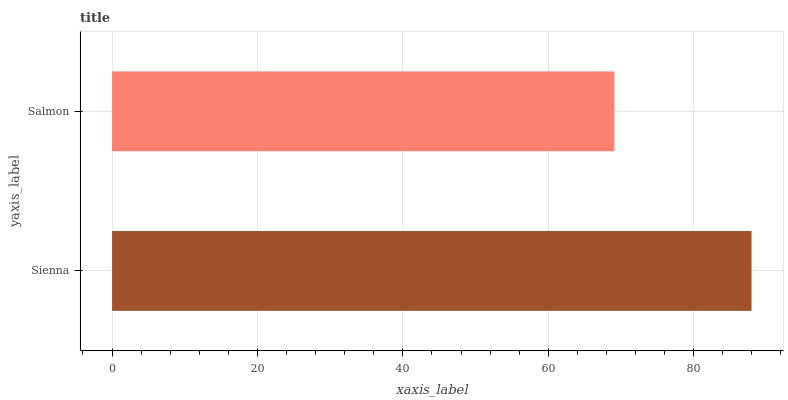Is Salmon the minimum?
Answer yes or no. Yes. Is Sienna the maximum?
Answer yes or no. Yes. Is Salmon the maximum?
Answer yes or no. No. Is Sienna greater than Salmon?
Answer yes or no. Yes. Is Salmon less than Sienna?
Answer yes or no. Yes. Is Salmon greater than Sienna?
Answer yes or no. No. Is Sienna less than Salmon?
Answer yes or no. No. Is Sienna the high median?
Answer yes or no. Yes. Is Salmon the low median?
Answer yes or no. Yes. Is Salmon the high median?
Answer yes or no. No. Is Sienna the low median?
Answer yes or no. No. 